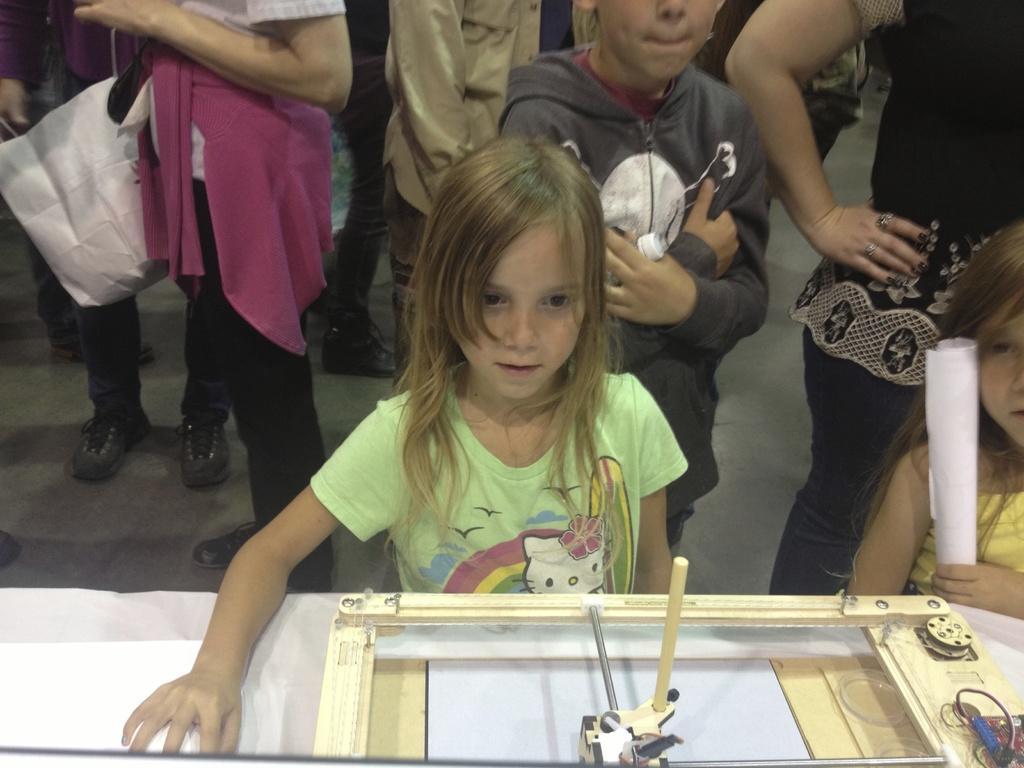How would you summarize this image in a sentence or two? In this picture we can see some persons are standing on the floor. And this is table. 